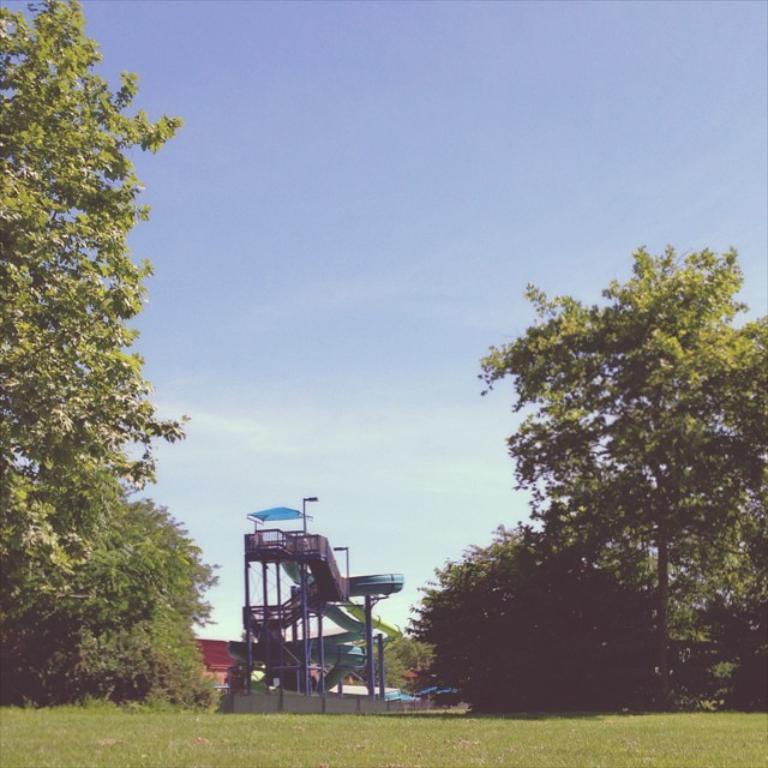In one or two sentences, can you explain what this image depicts? This image is clicked in a garden. In the front, we can see a slider. On the left and right, there are trees. At the bottom, there is green grass. At the top, there is sky in blue color. 